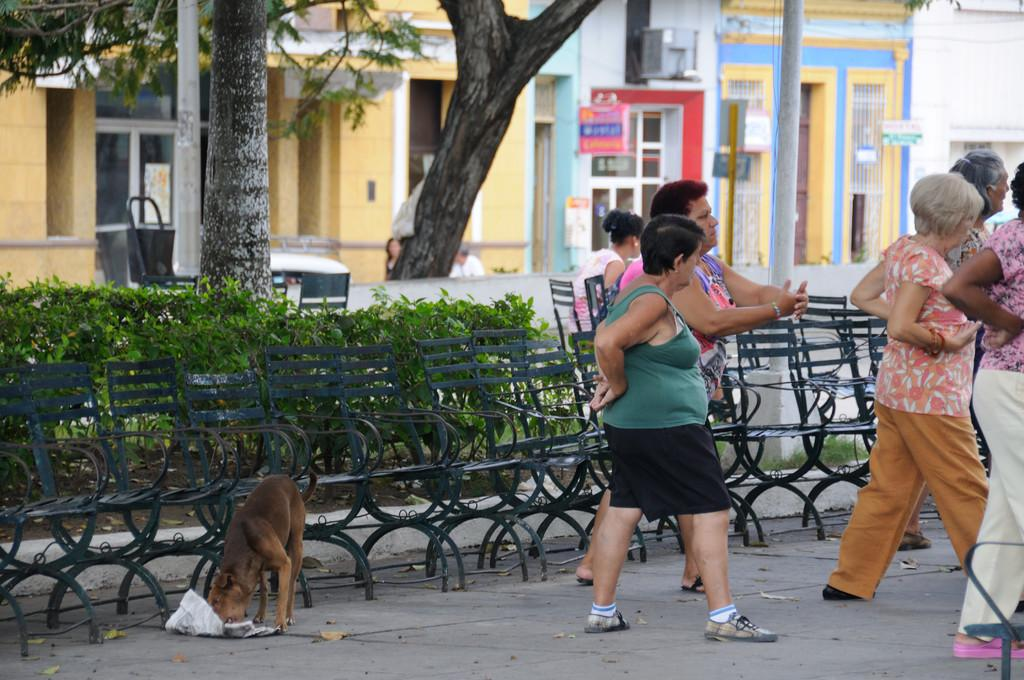What can be seen on the road in the image? There are people on the road in the image. What type of vegetation is present in the image? There are plants and trees in the image. What type of structures are visible in the image? There are buildings in the image. What animal is present in the image? There is a dog in the image. What is the name of the dog's owner in the image? There is no information about the dog's owner in the image. Can you hear the dog's horn in the image? Dogs do not have horns, so this question is not applicable to the image. 